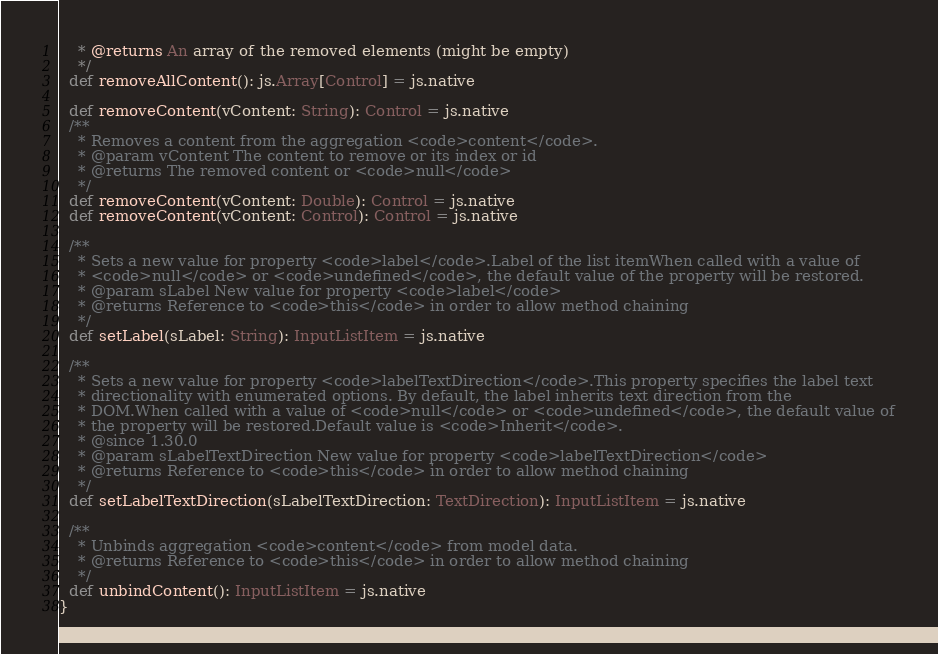Convert code to text. <code><loc_0><loc_0><loc_500><loc_500><_Scala_>    * @returns An array of the removed elements (might be empty)
    */
  def removeAllContent(): js.Array[Control] = js.native
  
  def removeContent(vContent: String): Control = js.native
  /**
    * Removes a content from the aggregation <code>content</code>.
    * @param vContent The content to remove or its index or id
    * @returns The removed content or <code>null</code>
    */
  def removeContent(vContent: Double): Control = js.native
  def removeContent(vContent: Control): Control = js.native
  
  /**
    * Sets a new value for property <code>label</code>.Label of the list itemWhen called with a value of
    * <code>null</code> or <code>undefined</code>, the default value of the property will be restored.
    * @param sLabel New value for property <code>label</code>
    * @returns Reference to <code>this</code> in order to allow method chaining
    */
  def setLabel(sLabel: String): InputListItem = js.native
  
  /**
    * Sets a new value for property <code>labelTextDirection</code>.This property specifies the label text
    * directionality with enumerated options. By default, the label inherits text direction from the
    * DOM.When called with a value of <code>null</code> or <code>undefined</code>, the default value of
    * the property will be restored.Default value is <code>Inherit</code>.
    * @since 1.30.0
    * @param sLabelTextDirection New value for property <code>labelTextDirection</code>
    * @returns Reference to <code>this</code> in order to allow method chaining
    */
  def setLabelTextDirection(sLabelTextDirection: TextDirection): InputListItem = js.native
  
  /**
    * Unbinds aggregation <code>content</code> from model data.
    * @returns Reference to <code>this</code> in order to allow method chaining
    */
  def unbindContent(): InputListItem = js.native
}
</code> 